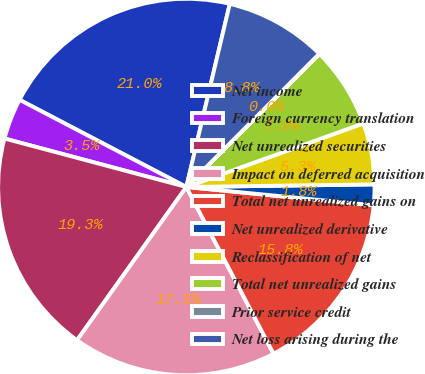<chart> <loc_0><loc_0><loc_500><loc_500><pie_chart><fcel>Net income<fcel>Foreign currency translation<fcel>Net unrealized securities<fcel>Impact on deferred acquisition<fcel>Total net unrealized gains on<fcel>Net unrealized derivative<fcel>Reclassification of net<fcel>Total net unrealized gains<fcel>Prior service credit<fcel>Net loss arising during the<nl><fcel>21.04%<fcel>3.52%<fcel>19.28%<fcel>17.53%<fcel>15.78%<fcel>1.77%<fcel>5.27%<fcel>7.02%<fcel>0.01%<fcel>8.77%<nl></chart> 